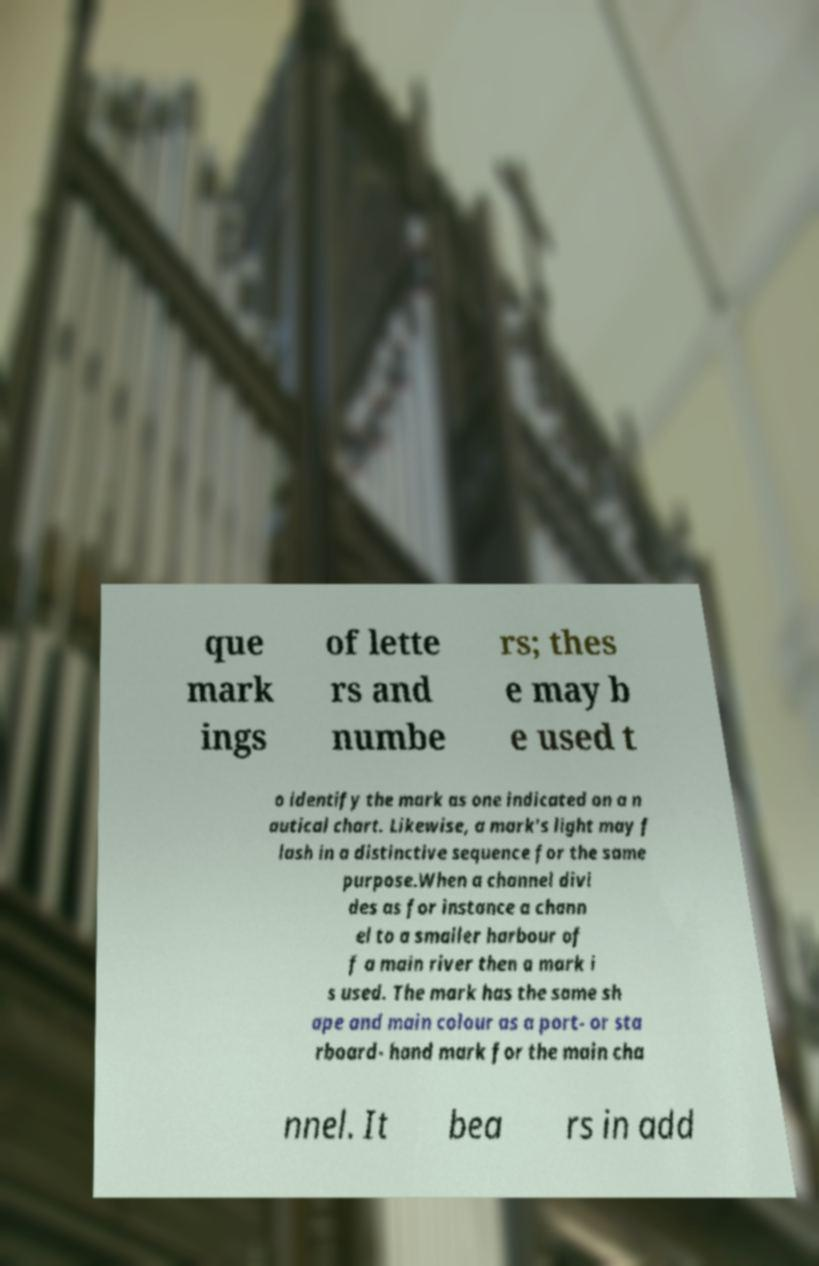I need the written content from this picture converted into text. Can you do that? que mark ings of lette rs and numbe rs; thes e may b e used t o identify the mark as one indicated on a n autical chart. Likewise, a mark's light may f lash in a distinctive sequence for the same purpose.When a channel divi des as for instance a chann el to a smaller harbour of f a main river then a mark i s used. The mark has the same sh ape and main colour as a port- or sta rboard- hand mark for the main cha nnel. It bea rs in add 